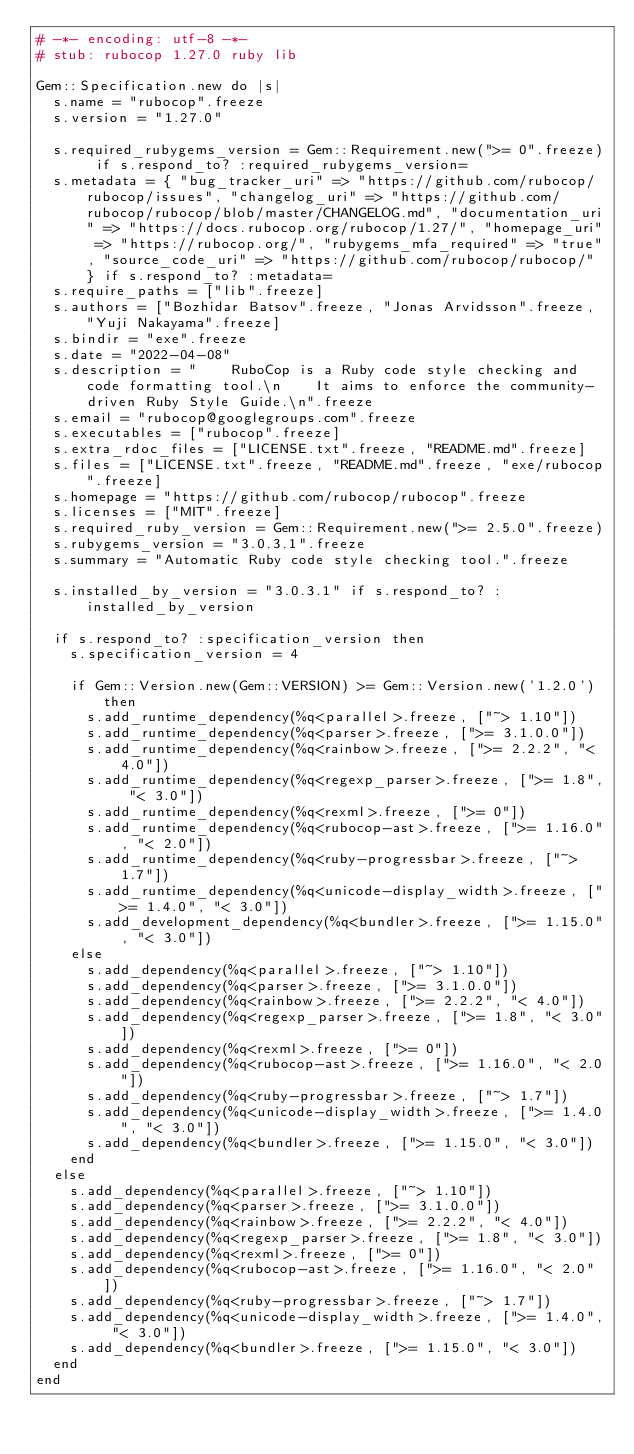<code> <loc_0><loc_0><loc_500><loc_500><_Ruby_># -*- encoding: utf-8 -*-
# stub: rubocop 1.27.0 ruby lib

Gem::Specification.new do |s|
  s.name = "rubocop".freeze
  s.version = "1.27.0"

  s.required_rubygems_version = Gem::Requirement.new(">= 0".freeze) if s.respond_to? :required_rubygems_version=
  s.metadata = { "bug_tracker_uri" => "https://github.com/rubocop/rubocop/issues", "changelog_uri" => "https://github.com/rubocop/rubocop/blob/master/CHANGELOG.md", "documentation_uri" => "https://docs.rubocop.org/rubocop/1.27/", "homepage_uri" => "https://rubocop.org/", "rubygems_mfa_required" => "true", "source_code_uri" => "https://github.com/rubocop/rubocop/" } if s.respond_to? :metadata=
  s.require_paths = ["lib".freeze]
  s.authors = ["Bozhidar Batsov".freeze, "Jonas Arvidsson".freeze, "Yuji Nakayama".freeze]
  s.bindir = "exe".freeze
  s.date = "2022-04-08"
  s.description = "    RuboCop is a Ruby code style checking and code formatting tool.\n    It aims to enforce the community-driven Ruby Style Guide.\n".freeze
  s.email = "rubocop@googlegroups.com".freeze
  s.executables = ["rubocop".freeze]
  s.extra_rdoc_files = ["LICENSE.txt".freeze, "README.md".freeze]
  s.files = ["LICENSE.txt".freeze, "README.md".freeze, "exe/rubocop".freeze]
  s.homepage = "https://github.com/rubocop/rubocop".freeze
  s.licenses = ["MIT".freeze]
  s.required_ruby_version = Gem::Requirement.new(">= 2.5.0".freeze)
  s.rubygems_version = "3.0.3.1".freeze
  s.summary = "Automatic Ruby code style checking tool.".freeze

  s.installed_by_version = "3.0.3.1" if s.respond_to? :installed_by_version

  if s.respond_to? :specification_version then
    s.specification_version = 4

    if Gem::Version.new(Gem::VERSION) >= Gem::Version.new('1.2.0') then
      s.add_runtime_dependency(%q<parallel>.freeze, ["~> 1.10"])
      s.add_runtime_dependency(%q<parser>.freeze, [">= 3.1.0.0"])
      s.add_runtime_dependency(%q<rainbow>.freeze, [">= 2.2.2", "< 4.0"])
      s.add_runtime_dependency(%q<regexp_parser>.freeze, [">= 1.8", "< 3.0"])
      s.add_runtime_dependency(%q<rexml>.freeze, [">= 0"])
      s.add_runtime_dependency(%q<rubocop-ast>.freeze, [">= 1.16.0", "< 2.0"])
      s.add_runtime_dependency(%q<ruby-progressbar>.freeze, ["~> 1.7"])
      s.add_runtime_dependency(%q<unicode-display_width>.freeze, [">= 1.4.0", "< 3.0"])
      s.add_development_dependency(%q<bundler>.freeze, [">= 1.15.0", "< 3.0"])
    else
      s.add_dependency(%q<parallel>.freeze, ["~> 1.10"])
      s.add_dependency(%q<parser>.freeze, [">= 3.1.0.0"])
      s.add_dependency(%q<rainbow>.freeze, [">= 2.2.2", "< 4.0"])
      s.add_dependency(%q<regexp_parser>.freeze, [">= 1.8", "< 3.0"])
      s.add_dependency(%q<rexml>.freeze, [">= 0"])
      s.add_dependency(%q<rubocop-ast>.freeze, [">= 1.16.0", "< 2.0"])
      s.add_dependency(%q<ruby-progressbar>.freeze, ["~> 1.7"])
      s.add_dependency(%q<unicode-display_width>.freeze, [">= 1.4.0", "< 3.0"])
      s.add_dependency(%q<bundler>.freeze, [">= 1.15.0", "< 3.0"])
    end
  else
    s.add_dependency(%q<parallel>.freeze, ["~> 1.10"])
    s.add_dependency(%q<parser>.freeze, [">= 3.1.0.0"])
    s.add_dependency(%q<rainbow>.freeze, [">= 2.2.2", "< 4.0"])
    s.add_dependency(%q<regexp_parser>.freeze, [">= 1.8", "< 3.0"])
    s.add_dependency(%q<rexml>.freeze, [">= 0"])
    s.add_dependency(%q<rubocop-ast>.freeze, [">= 1.16.0", "< 2.0"])
    s.add_dependency(%q<ruby-progressbar>.freeze, ["~> 1.7"])
    s.add_dependency(%q<unicode-display_width>.freeze, [">= 1.4.0", "< 3.0"])
    s.add_dependency(%q<bundler>.freeze, [">= 1.15.0", "< 3.0"])
  end
end
</code> 